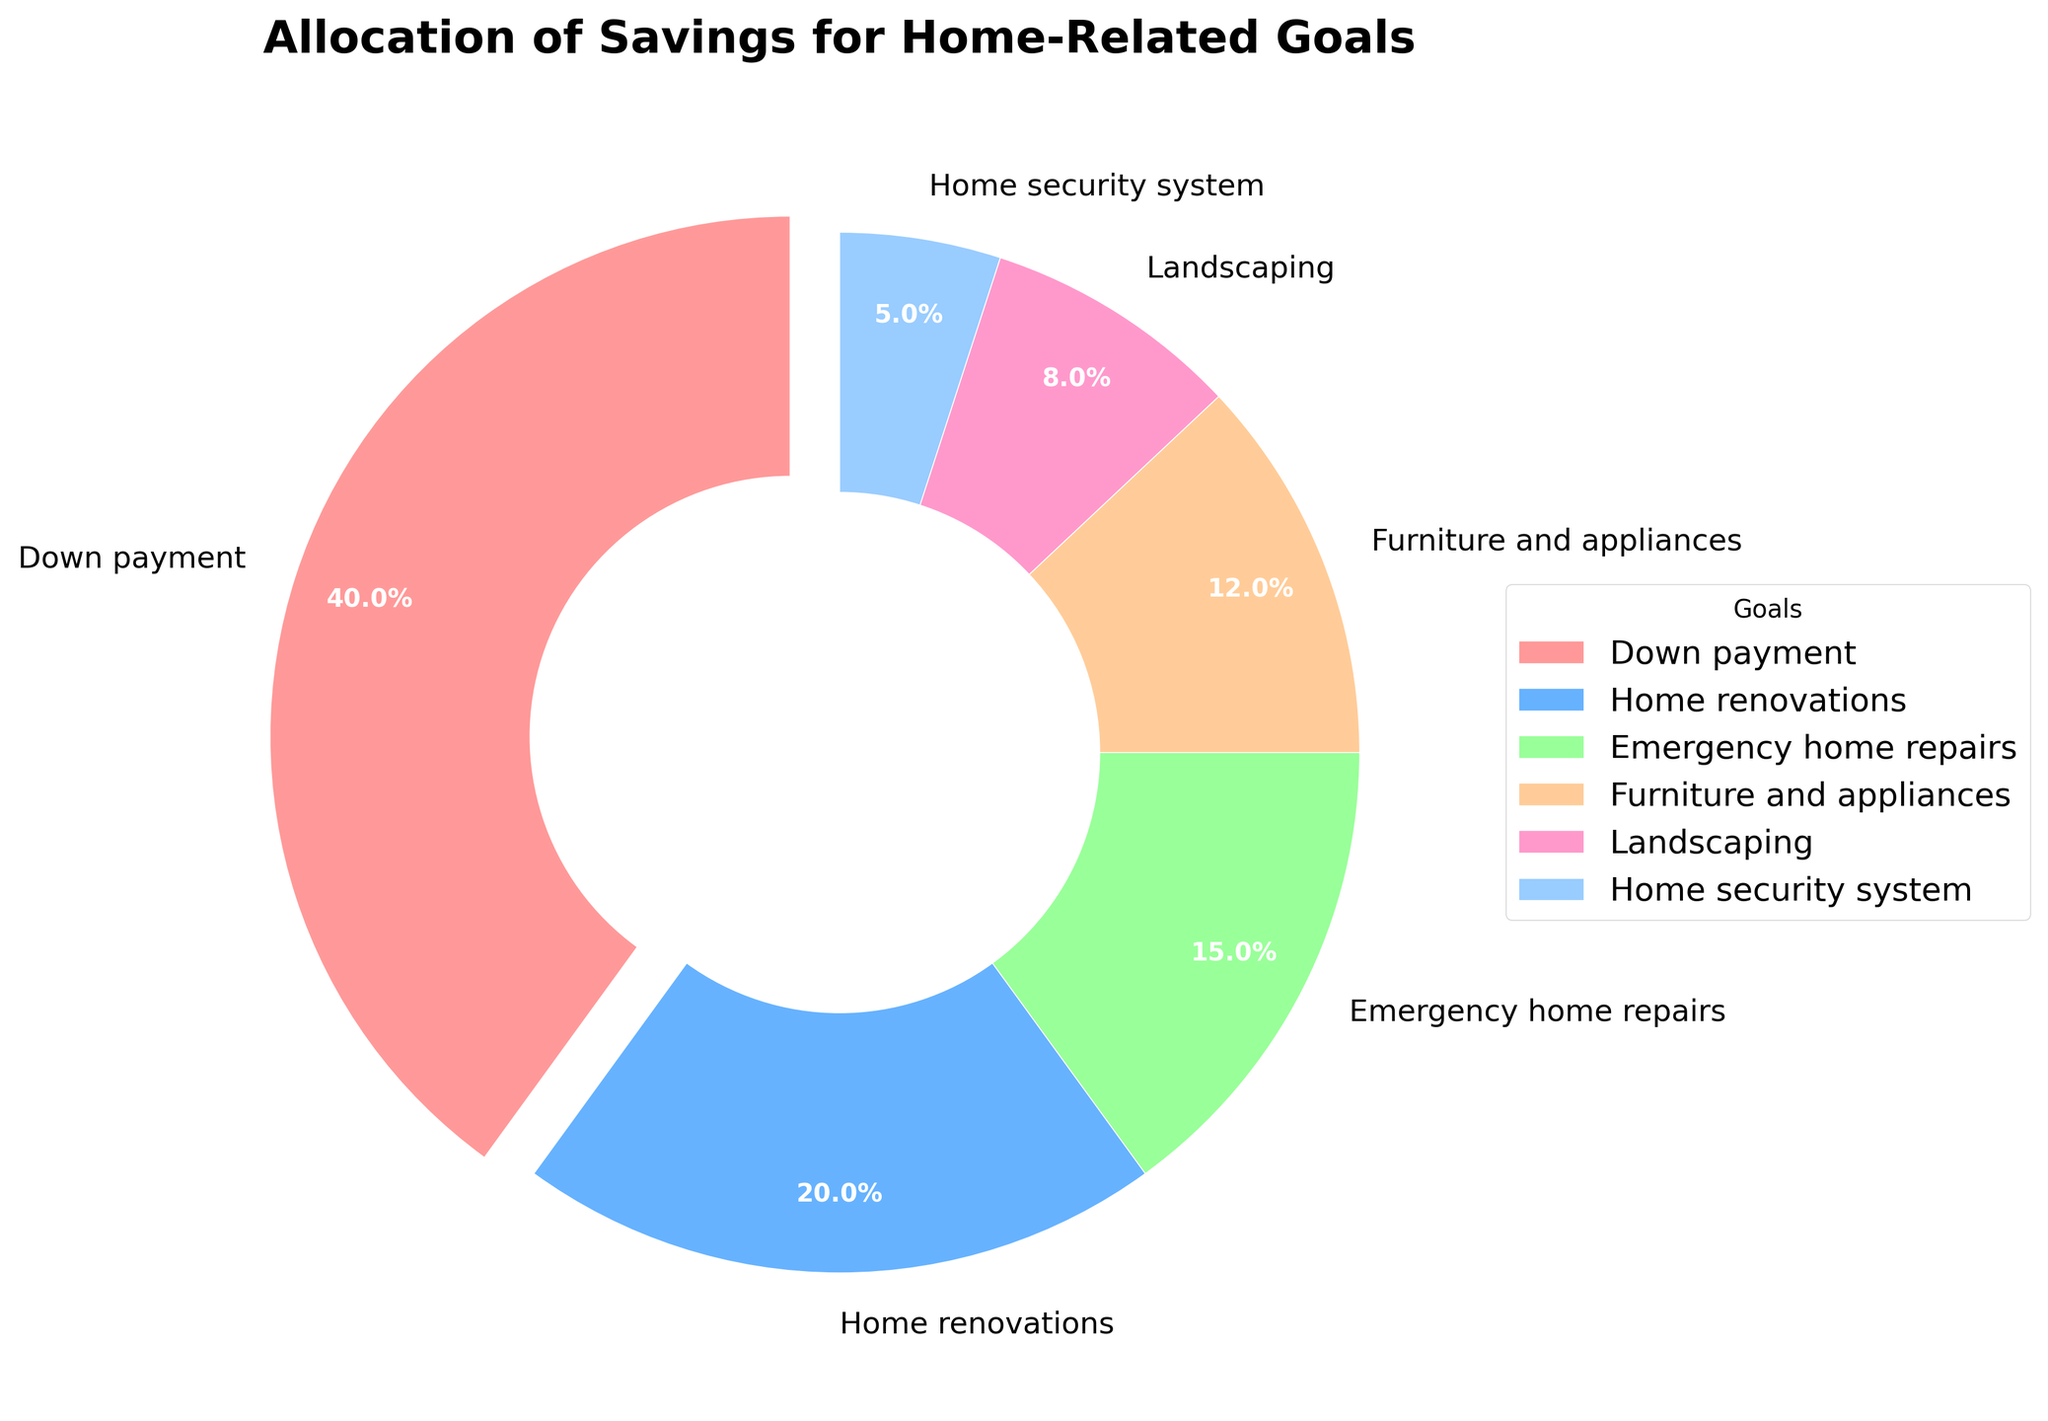What is the percentage allocated for home renovations? The pie chart shows a segment labeled "Home renovations" with a percentage next to it. By examining this label, we find the allocated percentage is 20%.
Answer: 20% What is the title of the chart? The title of the chart is directly displayed at the top of the figure. By reading it, we determine that the title is "Allocation of Savings for Home-Related Goals."
Answer: Allocation of Savings for Home-Related Goals Which goal has the smallest percentage allocation? Each segment of the pie chart has a label with its corresponding percentage. The goal with the smallest percentage is labeled "Home security system" with 5%.
Answer: Home security system How much more percentage is allocated to the down payment compared to furniture and appliances? The down payment is 40% and furniture and appliances is 12%. Subtracting 12 from 40 gives the additional percentage allocated to the down payment: 40% - 12% = 28%.
Answer: 28% What is the combined percentage allocation for emergency home repairs and landscaping? Emergency home repairs have a 15% allocation and landscaping has an 8% allocation. Adding these percentages together gives 15% + 8% = 23%.
Answer: 23% What is the color used to represent the down payment? Each segment of the pie chart is depicted with a different color. The segment for "Down payment" is colored in a light pinkish shade.
Answer: Light pink Is the percentage allocation for home renovations greater than that for landscaping? By comparing the percentages, home renovations have 20%, whereas landscaping has 8%. Therefore, home renovations have a greater allocation than landscaping.
Answer: Yes What are the top three goals based on their percentage allocations? By examining the segments and their corresponding percentages, the top three goals are Down payment (40%), Home renovations (20%), and Emergency home repairs (15%).
Answer: Down payment, Home renovations, Emergency home repairs What percentage of the savings is allocated to goals other than down payment? To find this, subtract the down payment percentage (40%) from 100%. The remaining percentage for other goals is 100% - 40% = 60%.
Answer: 60% How is the largest segment differentiated in the plot? The segment for the down payment, which is the largest, is emphasized by being slightly exploded (pulled out) from the pie chart.
Answer: It is exploded 